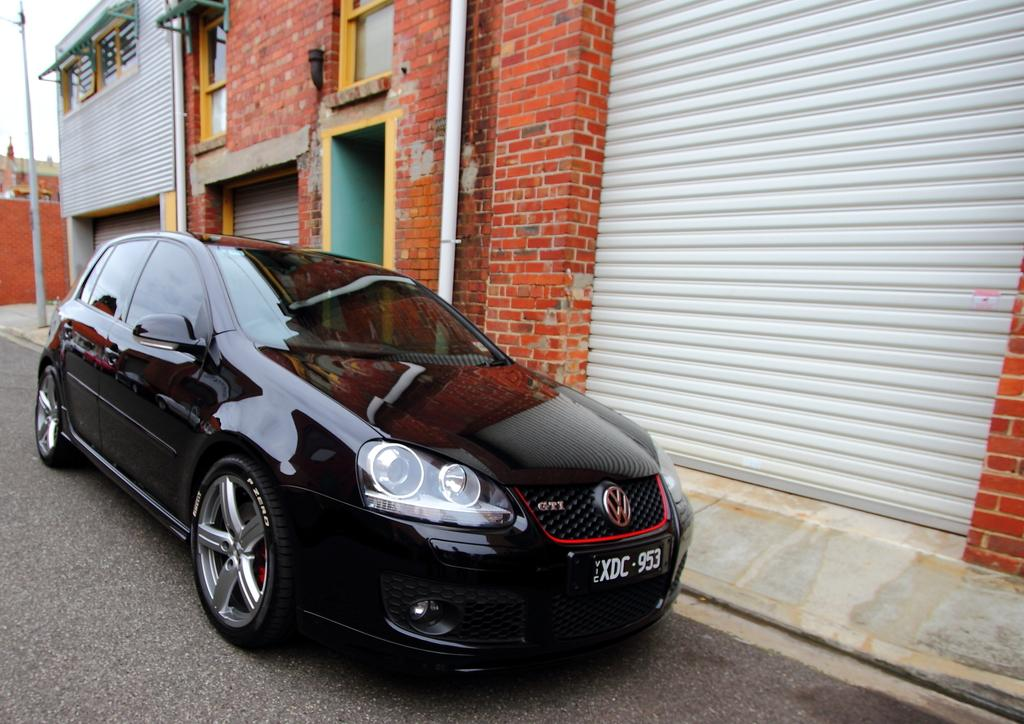What is the main subject of the image? There is a car in the image. What color is the car? The car is black. What can be seen in the background of the image? There are buildings in the background of the image. What color are the buildings? The buildings are brown. What is the color of the sky in the image? The sky is white in the image. How much rice is being transported in the car in the image? There is no rice visible in the image, and the car is not shown transporting anything. What type of carriage is present in the image? There is no carriage present in the image; it features a black car and brown buildings in the background. 